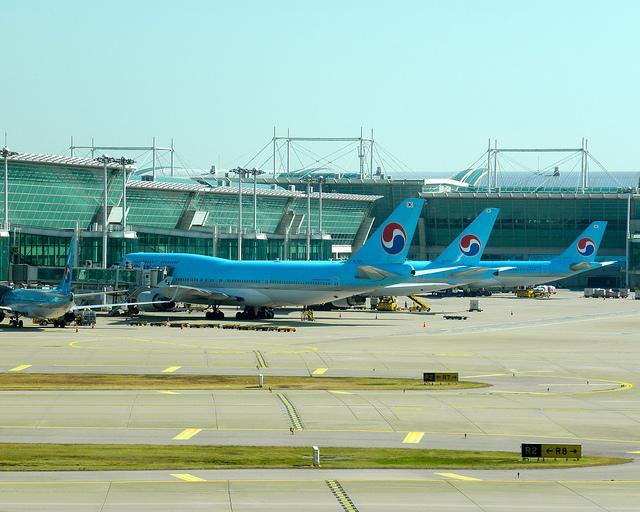The symbol on the planes looks like what logo? pepsi 